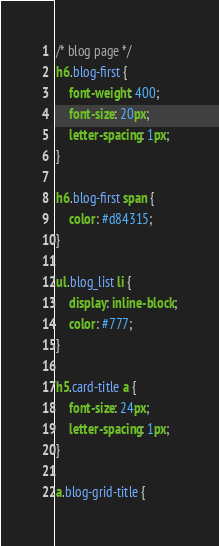<code> <loc_0><loc_0><loc_500><loc_500><_CSS_>/* blog page */
h6.blog-first {
    font-weight: 400;
    font-size: 20px;
    letter-spacing: 1px;
}

h6.blog-first span {
    color: #d84315;
}

ul.blog_list li {
    display: inline-block;
    color: #777;
}

h5.card-title a {
    font-size: 24px;
    letter-spacing: 1px;
}

a.blog-grid-title {</code> 